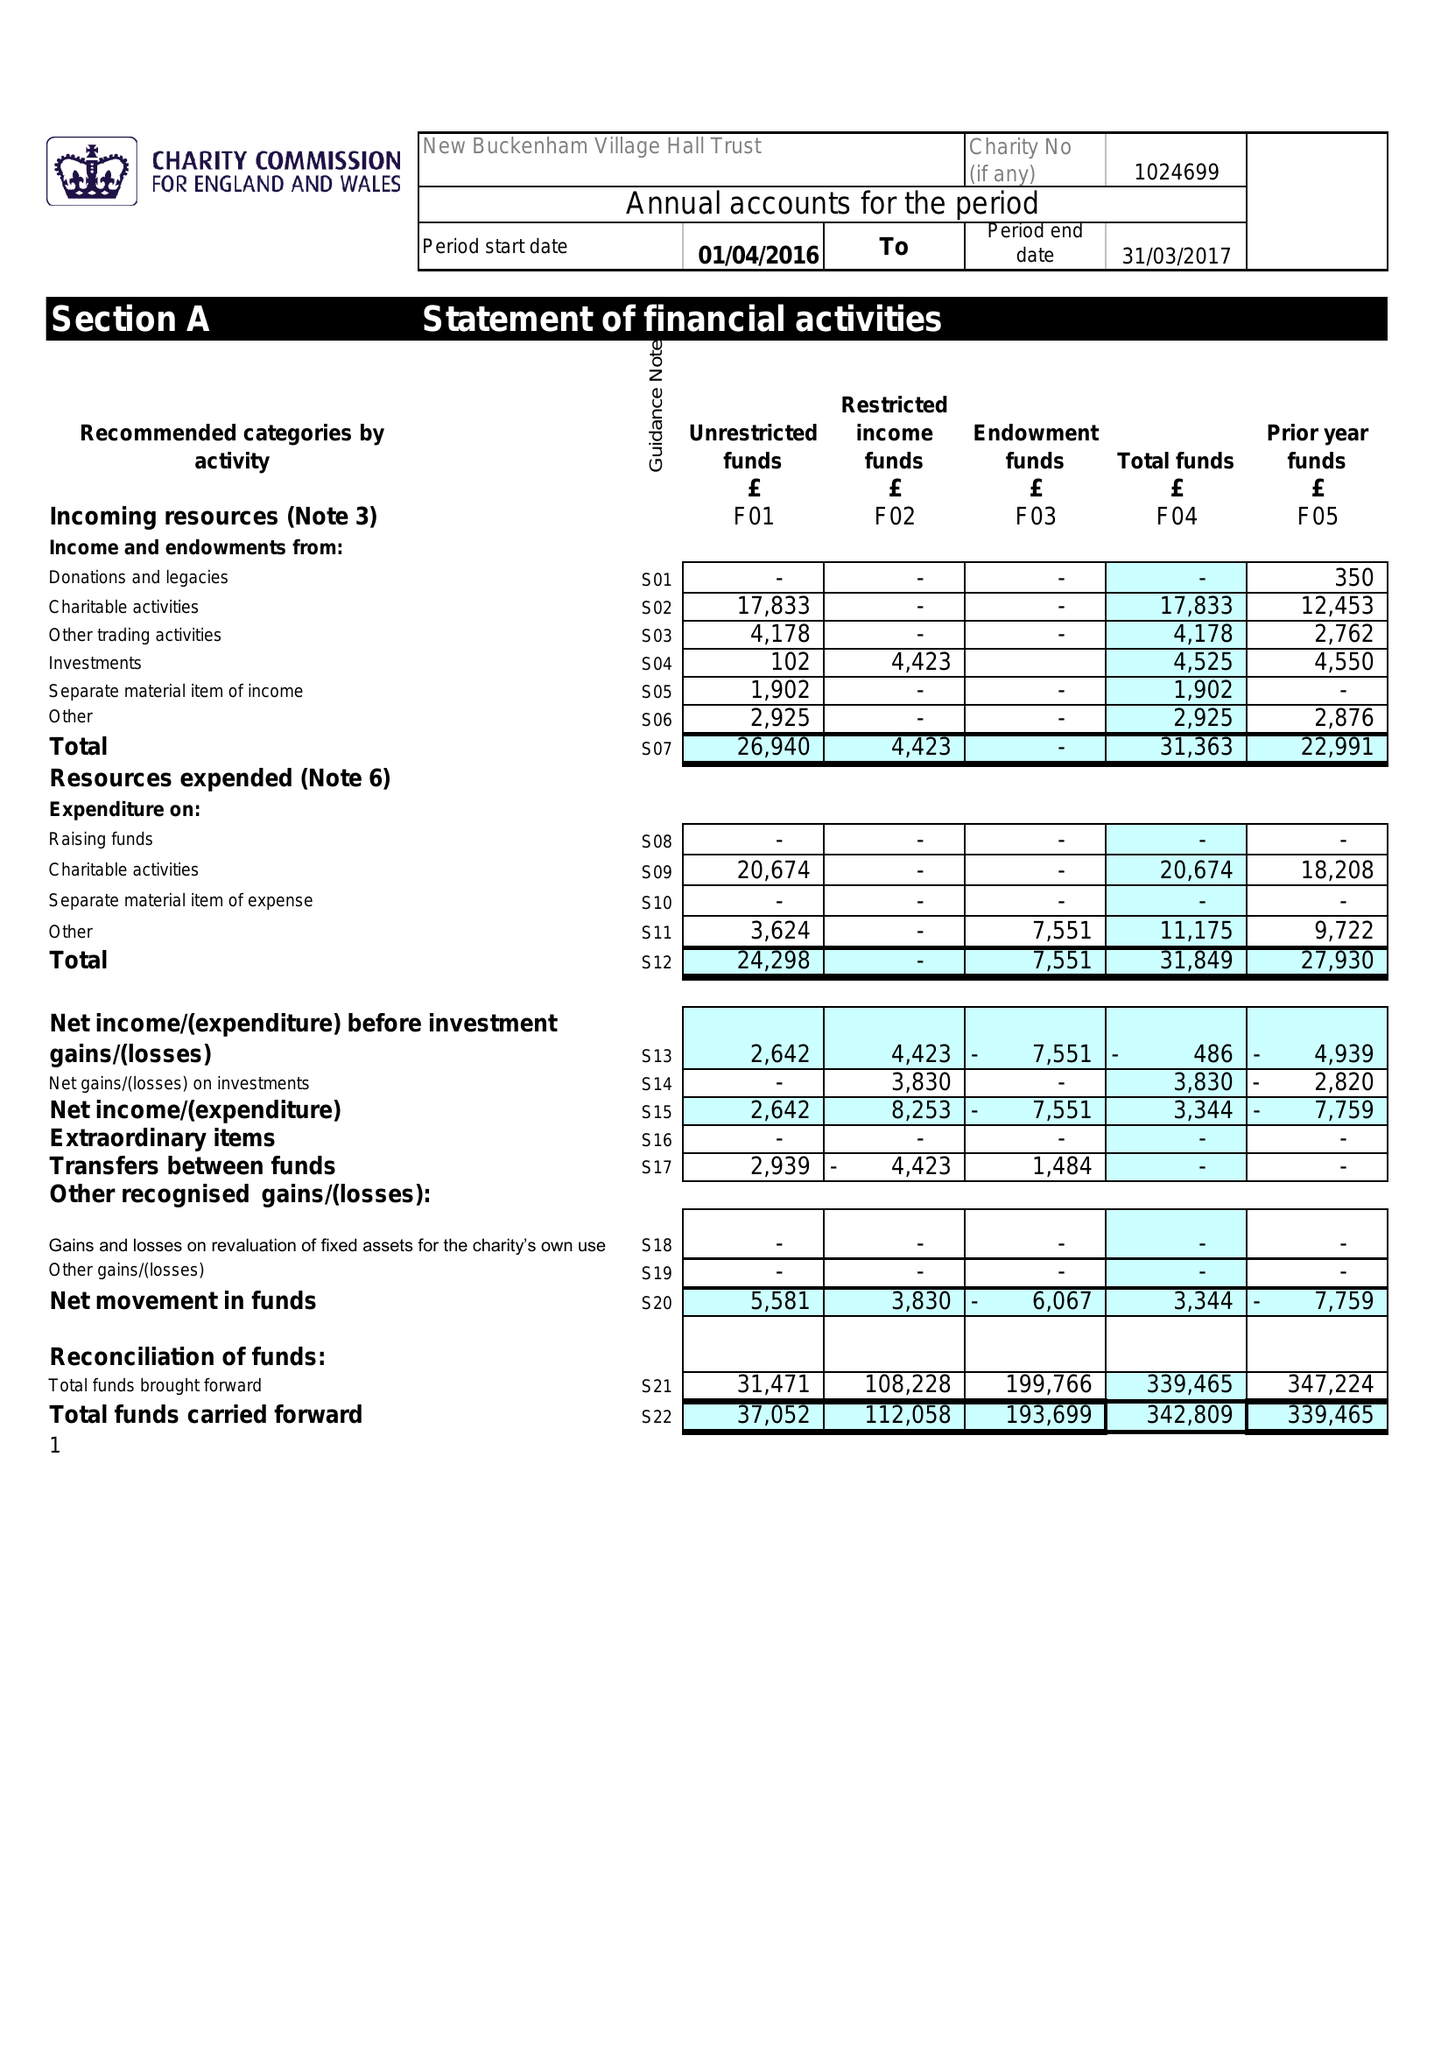What is the value for the spending_annually_in_british_pounds?
Answer the question using a single word or phrase. 31849.00 